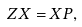<formula> <loc_0><loc_0><loc_500><loc_500>Z X = X P ,</formula> 